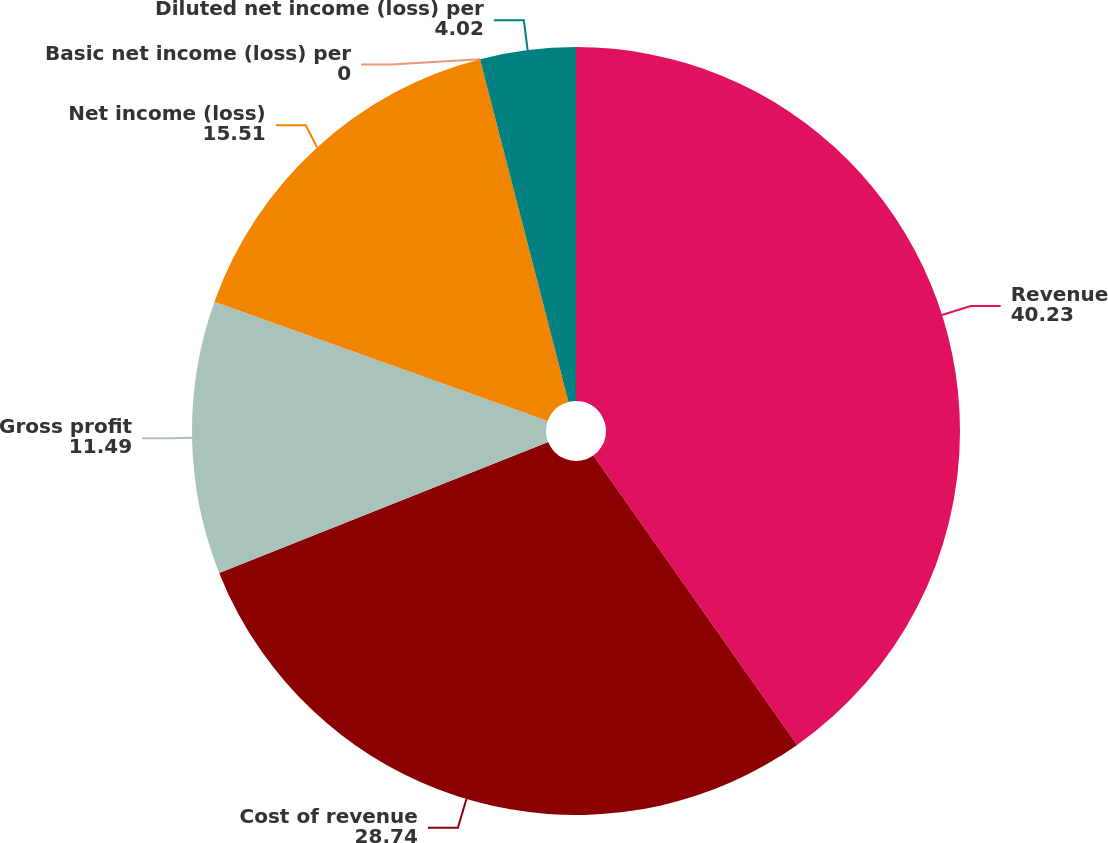Convert chart to OTSL. <chart><loc_0><loc_0><loc_500><loc_500><pie_chart><fcel>Revenue<fcel>Cost of revenue<fcel>Gross profit<fcel>Net income (loss)<fcel>Basic net income (loss) per<fcel>Diluted net income (loss) per<nl><fcel>40.23%<fcel>28.74%<fcel>11.49%<fcel>15.51%<fcel>0.0%<fcel>4.02%<nl></chart> 